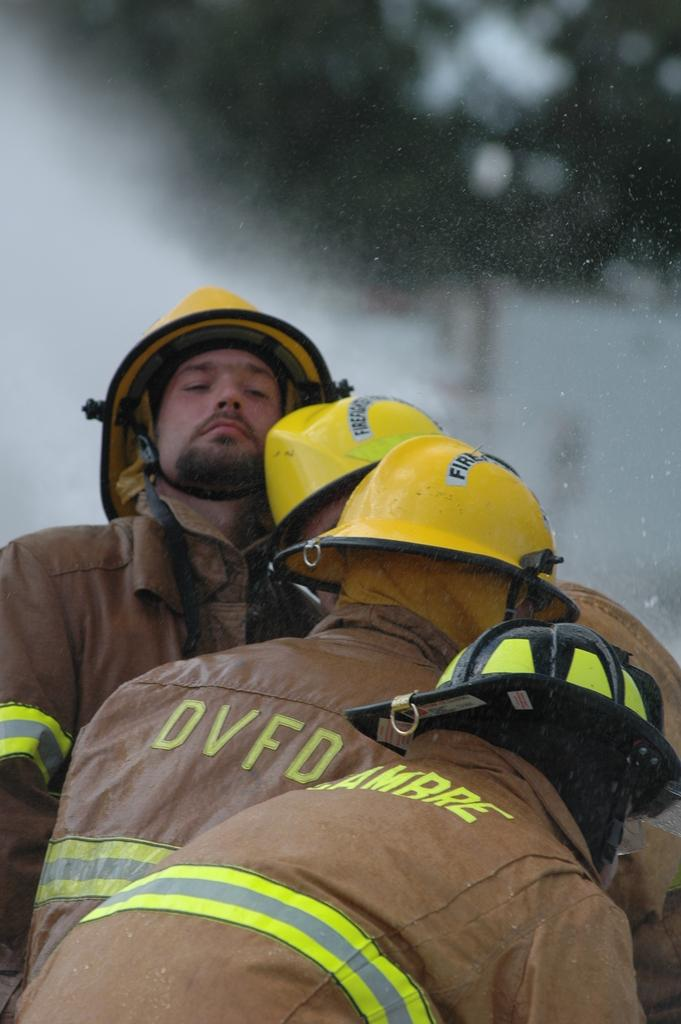Who or what is present in the image? There are people in the image. What are the people wearing in the image? The people are wearing jackets and yellow color helmets. Can you describe the background of the image? The background of the image is blurred. What type of eggnog is being served in the image? There is no eggnog present in the image. What tax-related information can be seen in the image? There is no tax-related information present in the image. 